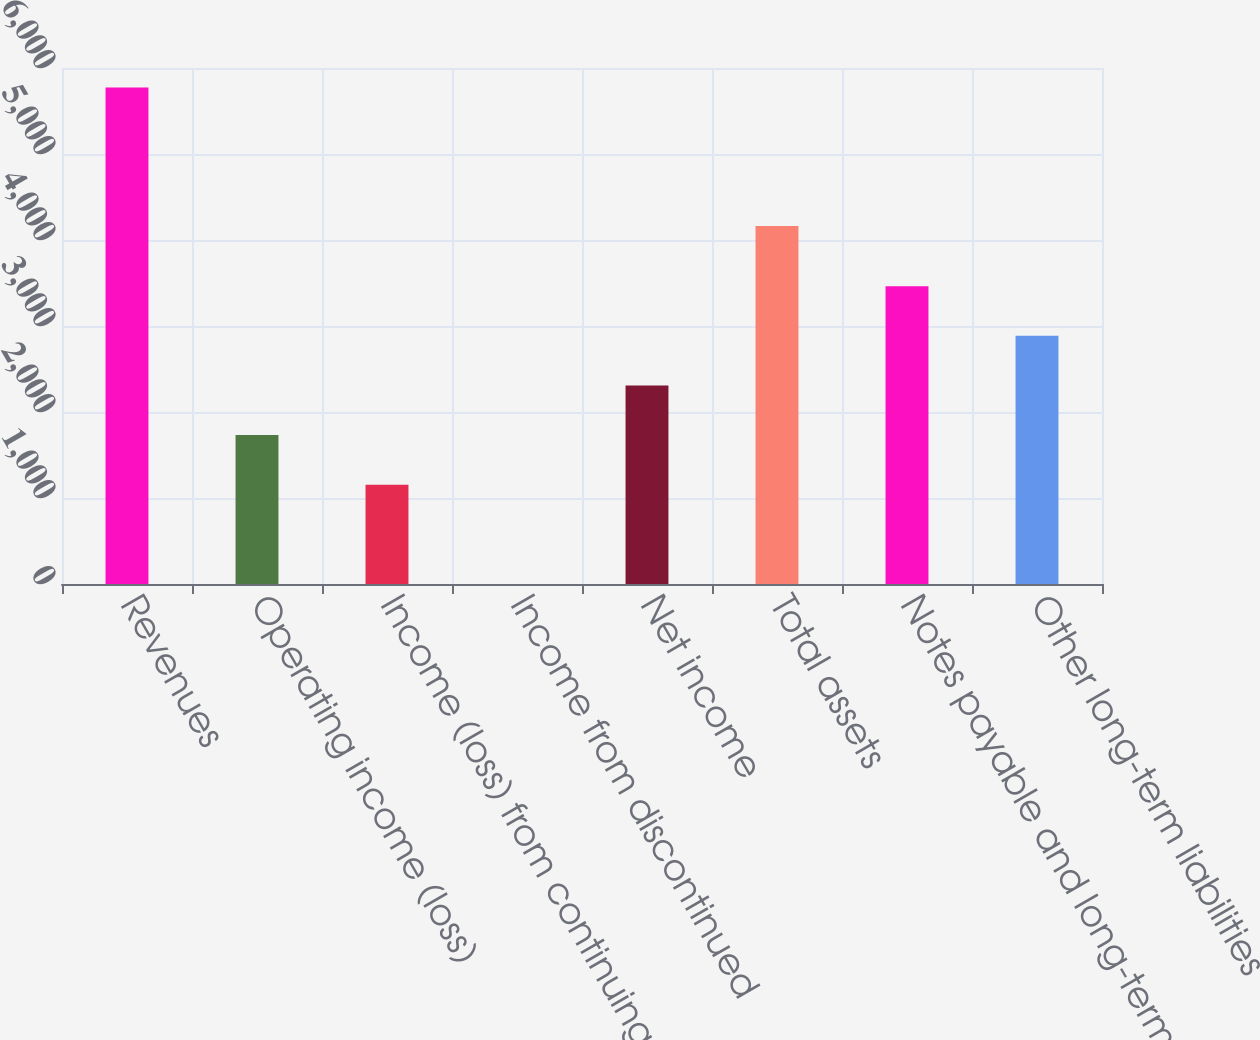Convert chart. <chart><loc_0><loc_0><loc_500><loc_500><bar_chart><fcel>Revenues<fcel>Operating income (loss)<fcel>Income (loss) from continuing<fcel>Income from discontinued<fcel>Net income<fcel>Total assets<fcel>Notes payable and long-term<fcel>Other long-term liabilities<nl><fcel>5772<fcel>1732.26<fcel>1155.16<fcel>0.96<fcel>2309.36<fcel>4162<fcel>3463.56<fcel>2886.46<nl></chart> 